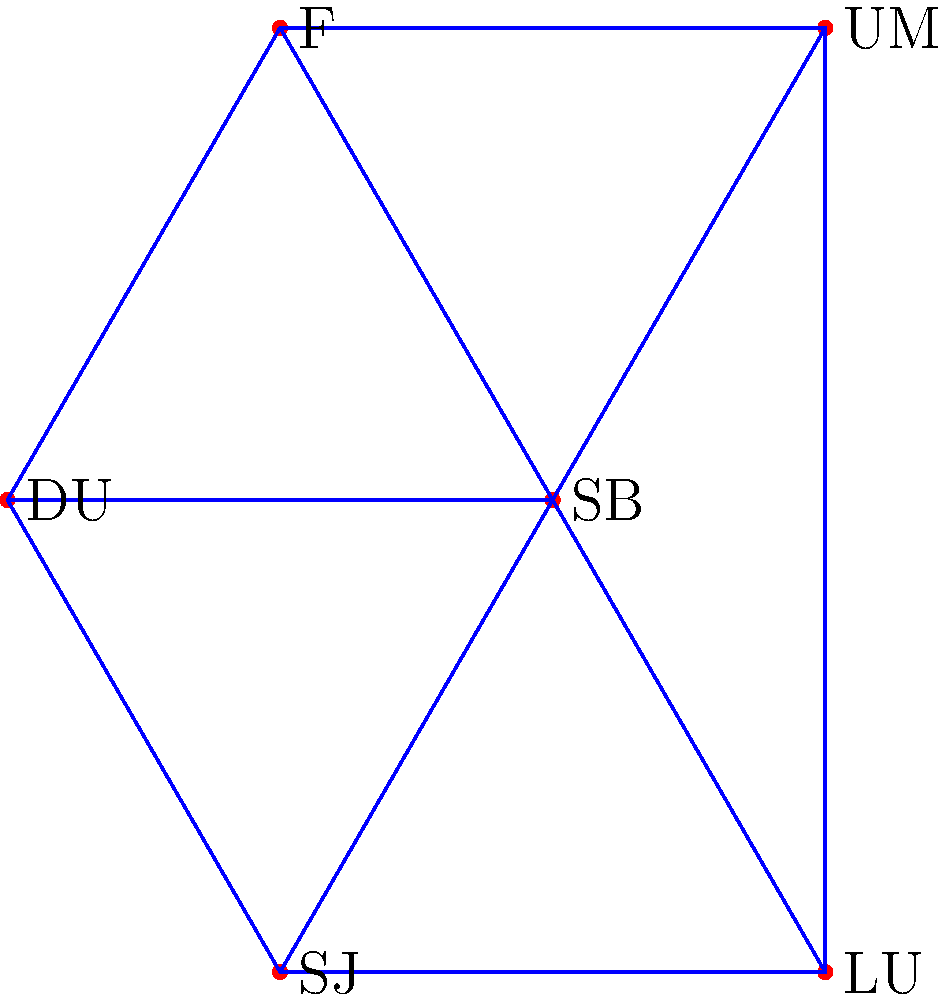Consider the simplicial complex shown above, which models Duquesne University's athletic conference structure. The vertices represent schools: DU (Duquesne), SB (St. Bonaventure), F (Fordham), SJ (Saint Joseph's), UM (UMass), and LU (La Salle). Edges represent rivalries, and triangles represent closely connected subgroups. What is the Euler characteristic of this simplicial complex? To find the Euler characteristic of this simplicial complex, we need to follow these steps:

1. Count the number of vertices (0-simplices):
   There are 6 vertices: DU, SB, F, SJ, UM, and LU.

2. Count the number of edges (1-simplices):
   There are 8 edges: DU-SB, DU-F, DU-SJ, SB-F, SB-SJ, SB-UM, SB-LU, and UM-LU.

3. Count the number of triangles (2-simplices):
   There are 3 triangles: DU-SB-F, DU-SB-SJ, and SB-UM-LU.

4. Calculate the Euler characteristic using the formula:
   $$ \chi = V - E + F $$
   Where:
   $\chi$ is the Euler characteristic
   $V$ is the number of vertices
   $E$ is the number of edges
   $F$ is the number of faces (triangles in this case)

5. Substitute the values:
   $$ \chi = 6 - 8 + 3 = 1 $$

Therefore, the Euler characteristic of this simplicial complex is 1.
Answer: 1 